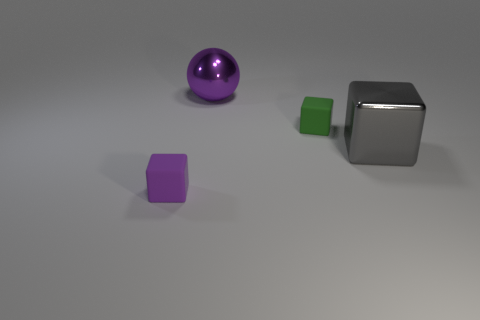Subtract all large cubes. How many cubes are left? 2 Add 1 big shiny things. How many objects exist? 5 Subtract all cyan cubes. Subtract all gray cylinders. How many cubes are left? 3 Subtract all cubes. How many objects are left? 1 Subtract 0 brown blocks. How many objects are left? 4 Subtract all large purple spheres. Subtract all purple shiny balls. How many objects are left? 2 Add 4 gray metal objects. How many gray metal objects are left? 5 Add 2 small yellow spheres. How many small yellow spheres exist? 2 